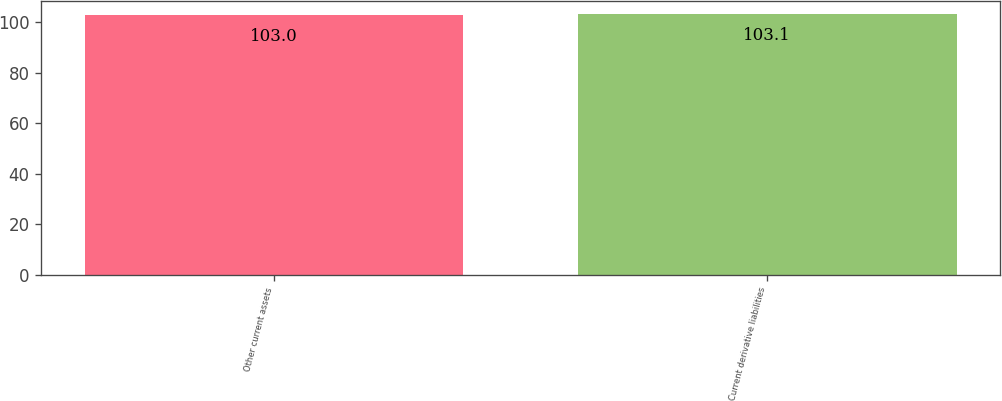Convert chart to OTSL. <chart><loc_0><loc_0><loc_500><loc_500><bar_chart><fcel>Other current assets<fcel>Current derivative liabilities<nl><fcel>103<fcel>103.1<nl></chart> 